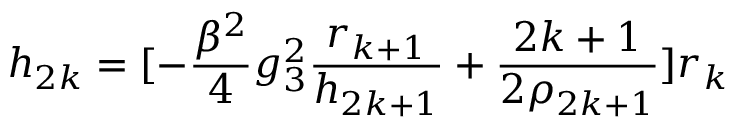<formula> <loc_0><loc_0><loc_500><loc_500>h _ { 2 k } = [ - \frac { \beta ^ { 2 } } { 4 } g _ { 3 } ^ { 2 } \frac { r _ { k + 1 } } { h _ { 2 k + 1 } } + \frac { 2 k + 1 } { 2 \rho _ { 2 k + 1 } } ] r _ { k }</formula> 